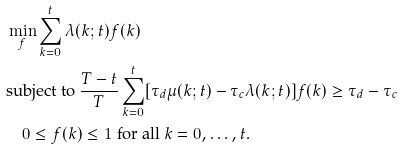Convert formula to latex. <formula><loc_0><loc_0><loc_500><loc_500>& \min _ { f } \sum _ { k = 0 } ^ { t } \lambda ( k ; t ) f ( k ) \\ & \text {subject to } \frac { T - t } { T } \sum _ { k = 0 } ^ { t } [ \tau _ { d } \mu ( k ; t ) - \tau _ { c } \lambda ( k ; t ) ] f ( k ) \geq \tau _ { d } - \tau _ { c } \\ & \quad 0 \leq f ( k ) \leq 1 \text { for all $k = 0, \dots, t$} .</formula> 